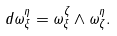Convert formula to latex. <formula><loc_0><loc_0><loc_500><loc_500>d \omega _ { \xi } ^ { \eta } = \omega _ { \xi } ^ { \zeta } \wedge \omega _ { \zeta } ^ { \eta } .</formula> 